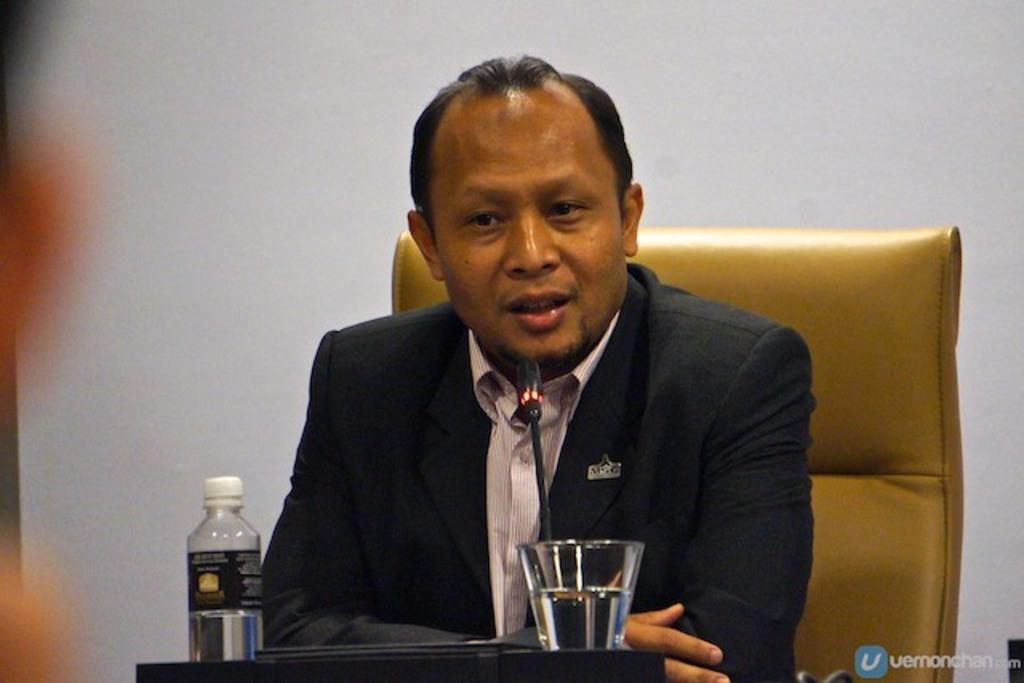What is the man in the image doing? The man is sitting on a chair in the image. What objects can be seen near the man? There is a bottle and a glass in the image. Where are the bottle and glass placed? The bottle and glass are placed on a surface. What can be seen in the background of the image? There is a wall visible in the image. What type of card is being developed in the image? There is no card or development process present in the image. Can you see any harbor in the image? There is no harbor visible in the image. 